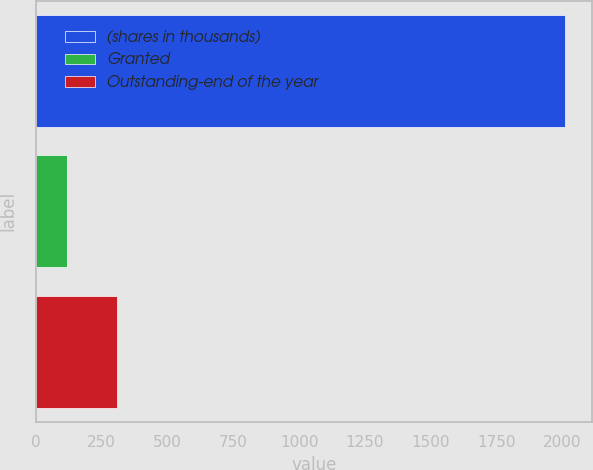Convert chart to OTSL. <chart><loc_0><loc_0><loc_500><loc_500><bar_chart><fcel>(shares in thousands)<fcel>Granted<fcel>Outstanding-end of the year<nl><fcel>2011<fcel>120<fcel>309.1<nl></chart> 